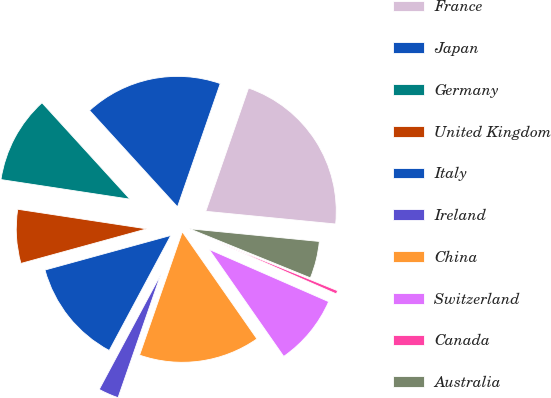<chart> <loc_0><loc_0><loc_500><loc_500><pie_chart><fcel>France<fcel>Japan<fcel>Germany<fcel>United Kingdom<fcel>Italy<fcel>Ireland<fcel>China<fcel>Switzerland<fcel>Canada<fcel>Australia<nl><fcel>21.24%<fcel>17.08%<fcel>10.83%<fcel>6.67%<fcel>12.91%<fcel>2.51%<fcel>15.0%<fcel>8.75%<fcel>0.42%<fcel>4.59%<nl></chart> 